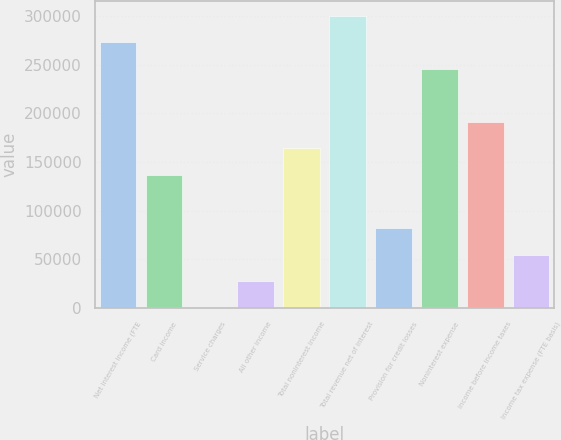Convert chart to OTSL. <chart><loc_0><loc_0><loc_500><loc_500><bar_chart><fcel>Net interest income (FTE<fcel>Card income<fcel>Service charges<fcel>All other income<fcel>Total noninterest income<fcel>Total revenue net of interest<fcel>Provision for credit losses<fcel>Noninterest expense<fcel>Income before income taxes<fcel>Income tax expense (FTE basis)<nl><fcel>273253<fcel>136627<fcel>1<fcel>27326.2<fcel>163952<fcel>300578<fcel>81976.6<fcel>245928<fcel>191277<fcel>54651.4<nl></chart> 